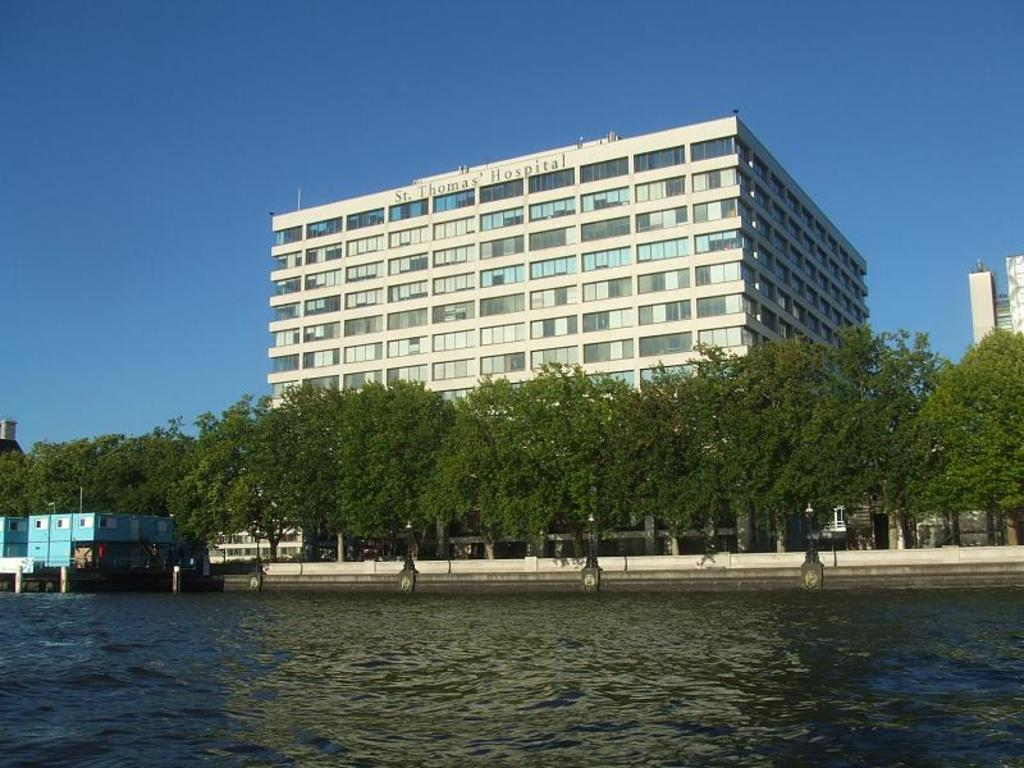What is the primary element visible in the image? There is water in the image. What other natural elements can be seen in the image? There are trees in the image. Are there any man-made structures visible? Yes, there are buildings in the image. What is visible in the background of the image? The sky is visible in the image. Is there any text or writing present in the image? Yes, there is text or writing present in the image. What type of stem can be seen growing from the water in the image? There is no stem visible in the image; it features water, trees, buildings, the sky, and text or writing. 